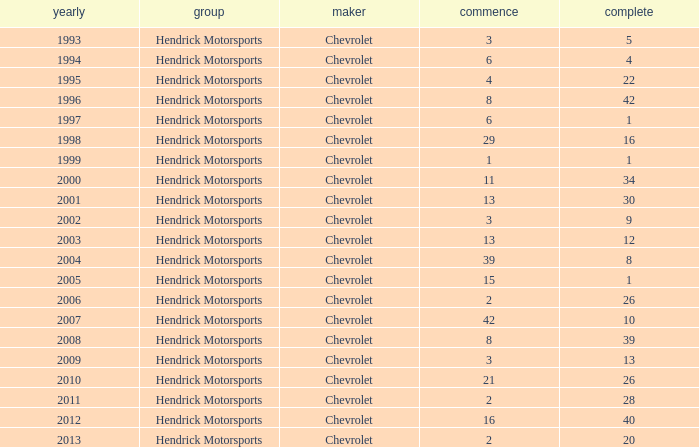What was Jeff's finish in 2011? 28.0. 